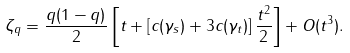<formula> <loc_0><loc_0><loc_500><loc_500>\zeta _ { q } = \frac { q ( 1 - q ) } { 2 } \left [ t + \left [ c ( \gamma _ { s } ) + 3 c ( \gamma _ { t } ) \right ] \frac { t ^ { 2 } } { 2 } \right ] + O ( t ^ { 3 } ) .</formula> 